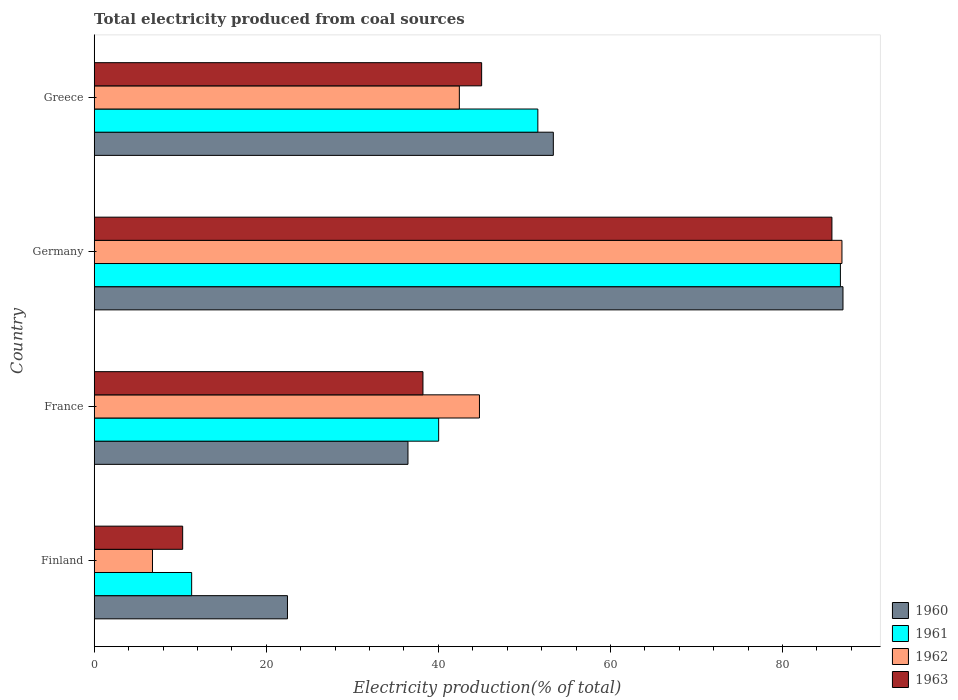Are the number of bars per tick equal to the number of legend labels?
Your answer should be compact. Yes. How many bars are there on the 1st tick from the bottom?
Make the answer very short. 4. What is the label of the 1st group of bars from the top?
Your response must be concise. Greece. In how many cases, is the number of bars for a given country not equal to the number of legend labels?
Give a very brief answer. 0. What is the total electricity produced in 1962 in Finland?
Ensure brevity in your answer.  6.78. Across all countries, what is the maximum total electricity produced in 1960?
Give a very brief answer. 87.03. Across all countries, what is the minimum total electricity produced in 1960?
Give a very brief answer. 22.46. In which country was the total electricity produced in 1961 maximum?
Your response must be concise. Germany. In which country was the total electricity produced in 1961 minimum?
Make the answer very short. Finland. What is the total total electricity produced in 1960 in the graph?
Make the answer very short. 199.32. What is the difference between the total electricity produced in 1960 in Finland and that in Germany?
Your answer should be very brief. -64.57. What is the difference between the total electricity produced in 1960 in France and the total electricity produced in 1961 in Finland?
Ensure brevity in your answer.  25.14. What is the average total electricity produced in 1961 per country?
Make the answer very short. 47.41. What is the difference between the total electricity produced in 1962 and total electricity produced in 1963 in Greece?
Your answer should be very brief. -2.59. What is the ratio of the total electricity produced in 1962 in Finland to that in Germany?
Provide a short and direct response. 0.08. Is the total electricity produced in 1962 in France less than that in Greece?
Provide a succinct answer. No. What is the difference between the highest and the second highest total electricity produced in 1963?
Make the answer very short. 40.71. What is the difference between the highest and the lowest total electricity produced in 1963?
Your answer should be compact. 75.46. In how many countries, is the total electricity produced in 1962 greater than the average total electricity produced in 1962 taken over all countries?
Ensure brevity in your answer.  1. Is it the case that in every country, the sum of the total electricity produced in 1963 and total electricity produced in 1962 is greater than the sum of total electricity produced in 1960 and total electricity produced in 1961?
Offer a very short reply. No. What does the 1st bar from the top in Greece represents?
Provide a short and direct response. 1963. Are all the bars in the graph horizontal?
Ensure brevity in your answer.  Yes. How many countries are there in the graph?
Ensure brevity in your answer.  4. What is the difference between two consecutive major ticks on the X-axis?
Your answer should be compact. 20. Are the values on the major ticks of X-axis written in scientific E-notation?
Your answer should be very brief. No. Does the graph contain grids?
Provide a succinct answer. No. How many legend labels are there?
Make the answer very short. 4. What is the title of the graph?
Your answer should be compact. Total electricity produced from coal sources. What is the Electricity production(% of total) in 1960 in Finland?
Your response must be concise. 22.46. What is the Electricity production(% of total) in 1961 in Finland?
Give a very brief answer. 11.33. What is the Electricity production(% of total) of 1962 in Finland?
Offer a very short reply. 6.78. What is the Electricity production(% of total) in 1963 in Finland?
Offer a terse response. 10.28. What is the Electricity production(% of total) in 1960 in France?
Your answer should be compact. 36.47. What is the Electricity production(% of total) in 1961 in France?
Provide a succinct answer. 40.03. What is the Electricity production(% of total) of 1962 in France?
Give a very brief answer. 44.78. What is the Electricity production(% of total) in 1963 in France?
Provide a succinct answer. 38.21. What is the Electricity production(% of total) in 1960 in Germany?
Keep it short and to the point. 87.03. What is the Electricity production(% of total) in 1961 in Germany?
Offer a terse response. 86.73. What is the Electricity production(% of total) of 1962 in Germany?
Give a very brief answer. 86.91. What is the Electricity production(% of total) in 1963 in Germany?
Provide a short and direct response. 85.74. What is the Electricity production(% of total) of 1960 in Greece?
Keep it short and to the point. 53.36. What is the Electricity production(% of total) in 1961 in Greece?
Your response must be concise. 51.56. What is the Electricity production(% of total) of 1962 in Greece?
Make the answer very short. 42.44. What is the Electricity production(% of total) of 1963 in Greece?
Your answer should be compact. 45.03. Across all countries, what is the maximum Electricity production(% of total) in 1960?
Make the answer very short. 87.03. Across all countries, what is the maximum Electricity production(% of total) of 1961?
Make the answer very short. 86.73. Across all countries, what is the maximum Electricity production(% of total) of 1962?
Your response must be concise. 86.91. Across all countries, what is the maximum Electricity production(% of total) in 1963?
Make the answer very short. 85.74. Across all countries, what is the minimum Electricity production(% of total) of 1960?
Ensure brevity in your answer.  22.46. Across all countries, what is the minimum Electricity production(% of total) in 1961?
Give a very brief answer. 11.33. Across all countries, what is the minimum Electricity production(% of total) in 1962?
Your answer should be very brief. 6.78. Across all countries, what is the minimum Electricity production(% of total) in 1963?
Keep it short and to the point. 10.28. What is the total Electricity production(% of total) in 1960 in the graph?
Provide a short and direct response. 199.32. What is the total Electricity production(% of total) of 1961 in the graph?
Make the answer very short. 189.65. What is the total Electricity production(% of total) of 1962 in the graph?
Make the answer very short. 180.9. What is the total Electricity production(% of total) in 1963 in the graph?
Provide a succinct answer. 179.27. What is the difference between the Electricity production(% of total) of 1960 in Finland and that in France?
Your response must be concise. -14.01. What is the difference between the Electricity production(% of total) in 1961 in Finland and that in France?
Provide a short and direct response. -28.71. What is the difference between the Electricity production(% of total) of 1962 in Finland and that in France?
Make the answer very short. -38. What is the difference between the Electricity production(% of total) in 1963 in Finland and that in France?
Your answer should be compact. -27.93. What is the difference between the Electricity production(% of total) in 1960 in Finland and that in Germany?
Your answer should be compact. -64.57. What is the difference between the Electricity production(% of total) in 1961 in Finland and that in Germany?
Your answer should be compact. -75.4. What is the difference between the Electricity production(% of total) in 1962 in Finland and that in Germany?
Your answer should be very brief. -80.13. What is the difference between the Electricity production(% of total) in 1963 in Finland and that in Germany?
Your answer should be compact. -75.46. What is the difference between the Electricity production(% of total) of 1960 in Finland and that in Greece?
Provide a succinct answer. -30.9. What is the difference between the Electricity production(% of total) in 1961 in Finland and that in Greece?
Offer a very short reply. -40.24. What is the difference between the Electricity production(% of total) of 1962 in Finland and that in Greece?
Provide a succinct answer. -35.66. What is the difference between the Electricity production(% of total) in 1963 in Finland and that in Greece?
Offer a very short reply. -34.75. What is the difference between the Electricity production(% of total) of 1960 in France and that in Germany?
Offer a very short reply. -50.56. What is the difference between the Electricity production(% of total) of 1961 in France and that in Germany?
Keep it short and to the point. -46.69. What is the difference between the Electricity production(% of total) of 1962 in France and that in Germany?
Make the answer very short. -42.13. What is the difference between the Electricity production(% of total) in 1963 in France and that in Germany?
Your response must be concise. -47.53. What is the difference between the Electricity production(% of total) of 1960 in France and that in Greece?
Keep it short and to the point. -16.89. What is the difference between the Electricity production(% of total) in 1961 in France and that in Greece?
Your response must be concise. -11.53. What is the difference between the Electricity production(% of total) in 1962 in France and that in Greece?
Ensure brevity in your answer.  2.34. What is the difference between the Electricity production(% of total) of 1963 in France and that in Greece?
Your answer should be very brief. -6.82. What is the difference between the Electricity production(% of total) in 1960 in Germany and that in Greece?
Provide a succinct answer. 33.67. What is the difference between the Electricity production(% of total) in 1961 in Germany and that in Greece?
Your answer should be compact. 35.16. What is the difference between the Electricity production(% of total) in 1962 in Germany and that in Greece?
Make the answer very short. 44.47. What is the difference between the Electricity production(% of total) of 1963 in Germany and that in Greece?
Offer a very short reply. 40.71. What is the difference between the Electricity production(% of total) in 1960 in Finland and the Electricity production(% of total) in 1961 in France?
Provide a short and direct response. -17.57. What is the difference between the Electricity production(% of total) of 1960 in Finland and the Electricity production(% of total) of 1962 in France?
Keep it short and to the point. -22.31. What is the difference between the Electricity production(% of total) in 1960 in Finland and the Electricity production(% of total) in 1963 in France?
Make the answer very short. -15.75. What is the difference between the Electricity production(% of total) in 1961 in Finland and the Electricity production(% of total) in 1962 in France?
Your answer should be compact. -33.45. What is the difference between the Electricity production(% of total) in 1961 in Finland and the Electricity production(% of total) in 1963 in France?
Offer a terse response. -26.88. What is the difference between the Electricity production(% of total) in 1962 in Finland and the Electricity production(% of total) in 1963 in France?
Your answer should be compact. -31.44. What is the difference between the Electricity production(% of total) of 1960 in Finland and the Electricity production(% of total) of 1961 in Germany?
Offer a terse response. -64.26. What is the difference between the Electricity production(% of total) of 1960 in Finland and the Electricity production(% of total) of 1962 in Germany?
Your response must be concise. -64.45. What is the difference between the Electricity production(% of total) of 1960 in Finland and the Electricity production(% of total) of 1963 in Germany?
Ensure brevity in your answer.  -63.28. What is the difference between the Electricity production(% of total) of 1961 in Finland and the Electricity production(% of total) of 1962 in Germany?
Give a very brief answer. -75.58. What is the difference between the Electricity production(% of total) of 1961 in Finland and the Electricity production(% of total) of 1963 in Germany?
Make the answer very short. -74.41. What is the difference between the Electricity production(% of total) of 1962 in Finland and the Electricity production(% of total) of 1963 in Germany?
Keep it short and to the point. -78.97. What is the difference between the Electricity production(% of total) of 1960 in Finland and the Electricity production(% of total) of 1961 in Greece?
Provide a succinct answer. -29.1. What is the difference between the Electricity production(% of total) in 1960 in Finland and the Electricity production(% of total) in 1962 in Greece?
Provide a succinct answer. -19.98. What is the difference between the Electricity production(% of total) in 1960 in Finland and the Electricity production(% of total) in 1963 in Greece?
Your answer should be very brief. -22.57. What is the difference between the Electricity production(% of total) in 1961 in Finland and the Electricity production(% of total) in 1962 in Greece?
Ensure brevity in your answer.  -31.11. What is the difference between the Electricity production(% of total) in 1961 in Finland and the Electricity production(% of total) in 1963 in Greece?
Keep it short and to the point. -33.7. What is the difference between the Electricity production(% of total) of 1962 in Finland and the Electricity production(% of total) of 1963 in Greece?
Make the answer very short. -38.26. What is the difference between the Electricity production(% of total) of 1960 in France and the Electricity production(% of total) of 1961 in Germany?
Your answer should be very brief. -50.26. What is the difference between the Electricity production(% of total) of 1960 in France and the Electricity production(% of total) of 1962 in Germany?
Provide a succinct answer. -50.44. What is the difference between the Electricity production(% of total) in 1960 in France and the Electricity production(% of total) in 1963 in Germany?
Make the answer very short. -49.27. What is the difference between the Electricity production(% of total) in 1961 in France and the Electricity production(% of total) in 1962 in Germany?
Your answer should be compact. -46.87. What is the difference between the Electricity production(% of total) of 1961 in France and the Electricity production(% of total) of 1963 in Germany?
Offer a terse response. -45.71. What is the difference between the Electricity production(% of total) in 1962 in France and the Electricity production(% of total) in 1963 in Germany?
Give a very brief answer. -40.97. What is the difference between the Electricity production(% of total) in 1960 in France and the Electricity production(% of total) in 1961 in Greece?
Give a very brief answer. -15.09. What is the difference between the Electricity production(% of total) of 1960 in France and the Electricity production(% of total) of 1962 in Greece?
Keep it short and to the point. -5.97. What is the difference between the Electricity production(% of total) in 1960 in France and the Electricity production(% of total) in 1963 in Greece?
Make the answer very short. -8.56. What is the difference between the Electricity production(% of total) in 1961 in France and the Electricity production(% of total) in 1962 in Greece?
Your response must be concise. -2.41. What is the difference between the Electricity production(% of total) in 1961 in France and the Electricity production(% of total) in 1963 in Greece?
Offer a very short reply. -5. What is the difference between the Electricity production(% of total) in 1962 in France and the Electricity production(% of total) in 1963 in Greece?
Ensure brevity in your answer.  -0.25. What is the difference between the Electricity production(% of total) of 1960 in Germany and the Electricity production(% of total) of 1961 in Greece?
Your response must be concise. 35.47. What is the difference between the Electricity production(% of total) of 1960 in Germany and the Electricity production(% of total) of 1962 in Greece?
Provide a short and direct response. 44.59. What is the difference between the Electricity production(% of total) in 1960 in Germany and the Electricity production(% of total) in 1963 in Greece?
Your response must be concise. 42. What is the difference between the Electricity production(% of total) of 1961 in Germany and the Electricity production(% of total) of 1962 in Greece?
Keep it short and to the point. 44.29. What is the difference between the Electricity production(% of total) of 1961 in Germany and the Electricity production(% of total) of 1963 in Greece?
Your response must be concise. 41.69. What is the difference between the Electricity production(% of total) of 1962 in Germany and the Electricity production(% of total) of 1963 in Greece?
Your answer should be very brief. 41.88. What is the average Electricity production(% of total) of 1960 per country?
Ensure brevity in your answer.  49.83. What is the average Electricity production(% of total) of 1961 per country?
Your answer should be compact. 47.41. What is the average Electricity production(% of total) of 1962 per country?
Give a very brief answer. 45.23. What is the average Electricity production(% of total) of 1963 per country?
Give a very brief answer. 44.82. What is the difference between the Electricity production(% of total) of 1960 and Electricity production(% of total) of 1961 in Finland?
Your answer should be very brief. 11.14. What is the difference between the Electricity production(% of total) of 1960 and Electricity production(% of total) of 1962 in Finland?
Offer a very short reply. 15.69. What is the difference between the Electricity production(% of total) in 1960 and Electricity production(% of total) in 1963 in Finland?
Offer a terse response. 12.18. What is the difference between the Electricity production(% of total) of 1961 and Electricity production(% of total) of 1962 in Finland?
Ensure brevity in your answer.  4.55. What is the difference between the Electricity production(% of total) in 1961 and Electricity production(% of total) in 1963 in Finland?
Keep it short and to the point. 1.04. What is the difference between the Electricity production(% of total) in 1962 and Electricity production(% of total) in 1963 in Finland?
Your answer should be very brief. -3.51. What is the difference between the Electricity production(% of total) of 1960 and Electricity production(% of total) of 1961 in France?
Ensure brevity in your answer.  -3.57. What is the difference between the Electricity production(% of total) in 1960 and Electricity production(% of total) in 1962 in France?
Offer a terse response. -8.31. What is the difference between the Electricity production(% of total) of 1960 and Electricity production(% of total) of 1963 in France?
Your answer should be compact. -1.74. What is the difference between the Electricity production(% of total) of 1961 and Electricity production(% of total) of 1962 in France?
Your answer should be compact. -4.74. What is the difference between the Electricity production(% of total) of 1961 and Electricity production(% of total) of 1963 in France?
Ensure brevity in your answer.  1.82. What is the difference between the Electricity production(% of total) in 1962 and Electricity production(% of total) in 1963 in France?
Offer a very short reply. 6.57. What is the difference between the Electricity production(% of total) of 1960 and Electricity production(% of total) of 1961 in Germany?
Make the answer very short. 0.3. What is the difference between the Electricity production(% of total) of 1960 and Electricity production(% of total) of 1962 in Germany?
Provide a succinct answer. 0.12. What is the difference between the Electricity production(% of total) in 1960 and Electricity production(% of total) in 1963 in Germany?
Provide a succinct answer. 1.29. What is the difference between the Electricity production(% of total) of 1961 and Electricity production(% of total) of 1962 in Germany?
Your answer should be compact. -0.18. What is the difference between the Electricity production(% of total) of 1961 and Electricity production(% of total) of 1963 in Germany?
Make the answer very short. 0.98. What is the difference between the Electricity production(% of total) in 1962 and Electricity production(% of total) in 1963 in Germany?
Give a very brief answer. 1.17. What is the difference between the Electricity production(% of total) in 1960 and Electricity production(% of total) in 1961 in Greece?
Keep it short and to the point. 1.8. What is the difference between the Electricity production(% of total) in 1960 and Electricity production(% of total) in 1962 in Greece?
Your answer should be very brief. 10.92. What is the difference between the Electricity production(% of total) in 1960 and Electricity production(% of total) in 1963 in Greece?
Your response must be concise. 8.33. What is the difference between the Electricity production(% of total) in 1961 and Electricity production(% of total) in 1962 in Greece?
Your response must be concise. 9.12. What is the difference between the Electricity production(% of total) of 1961 and Electricity production(% of total) of 1963 in Greece?
Your response must be concise. 6.53. What is the difference between the Electricity production(% of total) in 1962 and Electricity production(% of total) in 1963 in Greece?
Keep it short and to the point. -2.59. What is the ratio of the Electricity production(% of total) in 1960 in Finland to that in France?
Your answer should be compact. 0.62. What is the ratio of the Electricity production(% of total) in 1961 in Finland to that in France?
Your response must be concise. 0.28. What is the ratio of the Electricity production(% of total) in 1962 in Finland to that in France?
Give a very brief answer. 0.15. What is the ratio of the Electricity production(% of total) of 1963 in Finland to that in France?
Your response must be concise. 0.27. What is the ratio of the Electricity production(% of total) in 1960 in Finland to that in Germany?
Your answer should be compact. 0.26. What is the ratio of the Electricity production(% of total) in 1961 in Finland to that in Germany?
Your answer should be very brief. 0.13. What is the ratio of the Electricity production(% of total) of 1962 in Finland to that in Germany?
Your answer should be compact. 0.08. What is the ratio of the Electricity production(% of total) of 1963 in Finland to that in Germany?
Give a very brief answer. 0.12. What is the ratio of the Electricity production(% of total) in 1960 in Finland to that in Greece?
Make the answer very short. 0.42. What is the ratio of the Electricity production(% of total) in 1961 in Finland to that in Greece?
Offer a terse response. 0.22. What is the ratio of the Electricity production(% of total) of 1962 in Finland to that in Greece?
Offer a very short reply. 0.16. What is the ratio of the Electricity production(% of total) of 1963 in Finland to that in Greece?
Ensure brevity in your answer.  0.23. What is the ratio of the Electricity production(% of total) in 1960 in France to that in Germany?
Your answer should be very brief. 0.42. What is the ratio of the Electricity production(% of total) in 1961 in France to that in Germany?
Make the answer very short. 0.46. What is the ratio of the Electricity production(% of total) in 1962 in France to that in Germany?
Give a very brief answer. 0.52. What is the ratio of the Electricity production(% of total) in 1963 in France to that in Germany?
Make the answer very short. 0.45. What is the ratio of the Electricity production(% of total) of 1960 in France to that in Greece?
Provide a succinct answer. 0.68. What is the ratio of the Electricity production(% of total) of 1961 in France to that in Greece?
Ensure brevity in your answer.  0.78. What is the ratio of the Electricity production(% of total) of 1962 in France to that in Greece?
Provide a short and direct response. 1.06. What is the ratio of the Electricity production(% of total) in 1963 in France to that in Greece?
Your answer should be compact. 0.85. What is the ratio of the Electricity production(% of total) in 1960 in Germany to that in Greece?
Provide a short and direct response. 1.63. What is the ratio of the Electricity production(% of total) in 1961 in Germany to that in Greece?
Offer a very short reply. 1.68. What is the ratio of the Electricity production(% of total) in 1962 in Germany to that in Greece?
Offer a very short reply. 2.05. What is the ratio of the Electricity production(% of total) in 1963 in Germany to that in Greece?
Your answer should be compact. 1.9. What is the difference between the highest and the second highest Electricity production(% of total) in 1960?
Your answer should be very brief. 33.67. What is the difference between the highest and the second highest Electricity production(% of total) in 1961?
Your answer should be very brief. 35.16. What is the difference between the highest and the second highest Electricity production(% of total) in 1962?
Provide a short and direct response. 42.13. What is the difference between the highest and the second highest Electricity production(% of total) in 1963?
Make the answer very short. 40.71. What is the difference between the highest and the lowest Electricity production(% of total) of 1960?
Your answer should be compact. 64.57. What is the difference between the highest and the lowest Electricity production(% of total) in 1961?
Your answer should be very brief. 75.4. What is the difference between the highest and the lowest Electricity production(% of total) in 1962?
Ensure brevity in your answer.  80.13. What is the difference between the highest and the lowest Electricity production(% of total) of 1963?
Your response must be concise. 75.46. 